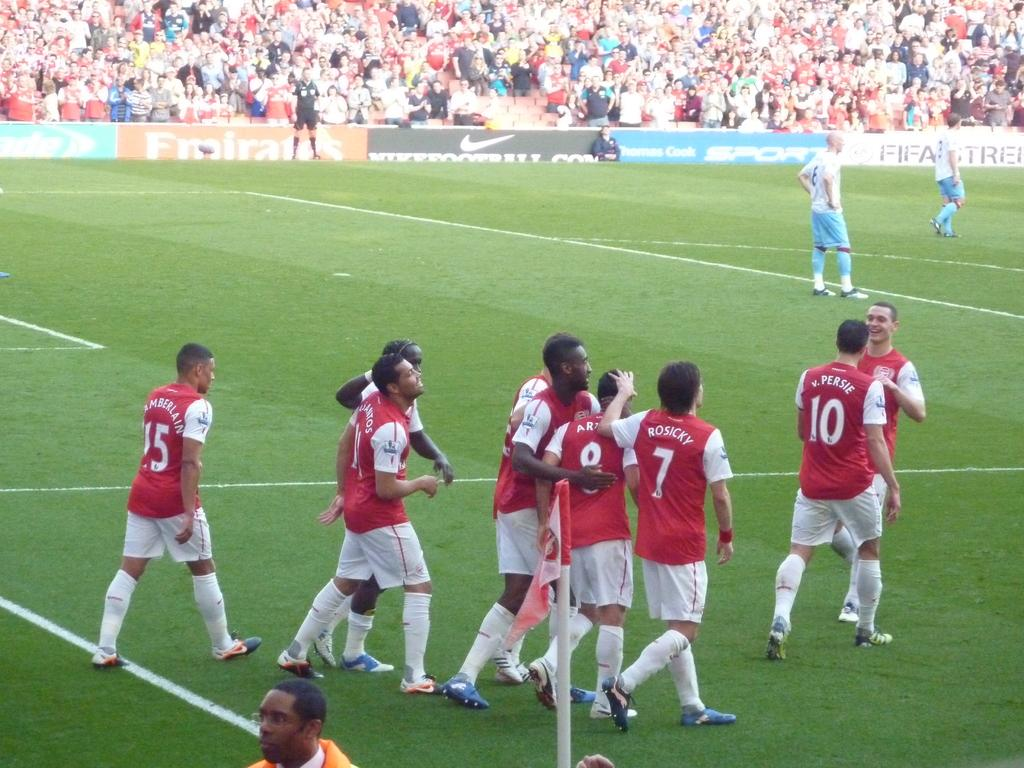<image>
Share a concise interpretation of the image provided. A group of soccer players in red jerseys with white shorts walk together near the soccer pitch with a Fifa advertisement on the other side of the field. 